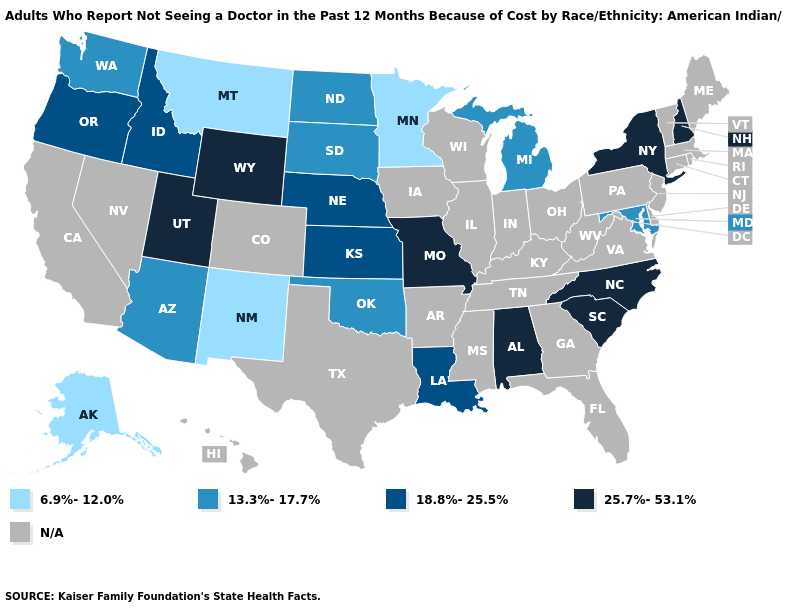Name the states that have a value in the range 25.7%-53.1%?
Give a very brief answer. Alabama, Missouri, New Hampshire, New York, North Carolina, South Carolina, Utah, Wyoming. What is the value of Alabama?
Short answer required. 25.7%-53.1%. Which states have the highest value in the USA?
Be succinct. Alabama, Missouri, New Hampshire, New York, North Carolina, South Carolina, Utah, Wyoming. What is the highest value in the South ?
Quick response, please. 25.7%-53.1%. Name the states that have a value in the range 18.8%-25.5%?
Write a very short answer. Idaho, Kansas, Louisiana, Nebraska, Oregon. What is the highest value in the MidWest ?
Be succinct. 25.7%-53.1%. What is the lowest value in states that border Iowa?
Write a very short answer. 6.9%-12.0%. Which states have the lowest value in the USA?
Give a very brief answer. Alaska, Minnesota, Montana, New Mexico. Name the states that have a value in the range N/A?
Quick response, please. Arkansas, California, Colorado, Connecticut, Delaware, Florida, Georgia, Hawaii, Illinois, Indiana, Iowa, Kentucky, Maine, Massachusetts, Mississippi, Nevada, New Jersey, Ohio, Pennsylvania, Rhode Island, Tennessee, Texas, Vermont, Virginia, West Virginia, Wisconsin. What is the value of Pennsylvania?
Write a very short answer. N/A. How many symbols are there in the legend?
Write a very short answer. 5. Among the states that border Connecticut , which have the lowest value?
Write a very short answer. New York. Name the states that have a value in the range 13.3%-17.7%?
Answer briefly. Arizona, Maryland, Michigan, North Dakota, Oklahoma, South Dakota, Washington. 